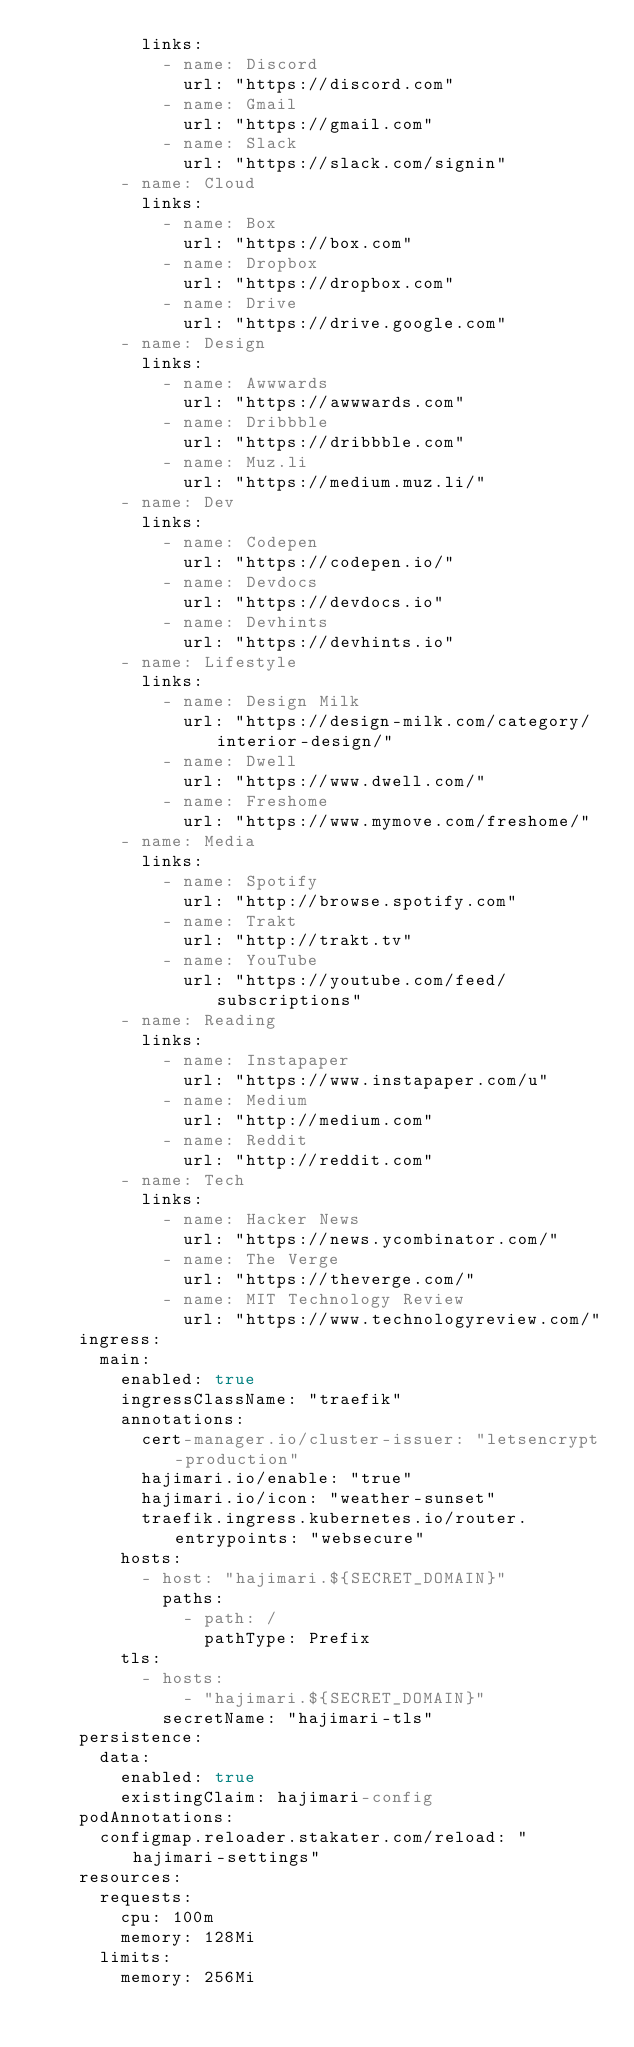Convert code to text. <code><loc_0><loc_0><loc_500><loc_500><_YAML_>          links:
            - name: Discord
              url: "https://discord.com"
            - name: Gmail
              url: "https://gmail.com"
            - name: Slack
              url: "https://slack.com/signin"
        - name: Cloud
          links:
            - name: Box
              url: "https://box.com"
            - name: Dropbox
              url: "https://dropbox.com"
            - name: Drive
              url: "https://drive.google.com"
        - name: Design
          links:
            - name: Awwwards
              url: "https://awwwards.com"
            - name: Dribbble
              url: "https://dribbble.com"
            - name: Muz.li
              url: "https://medium.muz.li/"
        - name: Dev
          links:
            - name: Codepen
              url: "https://codepen.io/"
            - name: Devdocs
              url: "https://devdocs.io"
            - name: Devhints
              url: "https://devhints.io"
        - name: Lifestyle
          links:
            - name: Design Milk
              url: "https://design-milk.com/category/interior-design/"
            - name: Dwell
              url: "https://www.dwell.com/"
            - name: Freshome
              url: "https://www.mymove.com/freshome/"
        - name: Media
          links:
            - name: Spotify
              url: "http://browse.spotify.com"
            - name: Trakt
              url: "http://trakt.tv"
            - name: YouTube
              url: "https://youtube.com/feed/subscriptions"
        - name: Reading
          links:
            - name: Instapaper
              url: "https://www.instapaper.com/u"
            - name: Medium
              url: "http://medium.com"
            - name: Reddit
              url: "http://reddit.com"
        - name: Tech
          links:
            - name: Hacker News
              url: "https://news.ycombinator.com/"
            - name: The Verge
              url: "https://theverge.com/"
            - name: MIT Technology Review
              url: "https://www.technologyreview.com/"
    ingress:
      main:
        enabled: true
        ingressClassName: "traefik"
        annotations:
          cert-manager.io/cluster-issuer: "letsencrypt-production"
          hajimari.io/enable: "true"
          hajimari.io/icon: "weather-sunset"
          traefik.ingress.kubernetes.io/router.entrypoints: "websecure"
        hosts:
          - host: "hajimari.${SECRET_DOMAIN}"
            paths:
              - path: /
                pathType: Prefix
        tls:
          - hosts:
              - "hajimari.${SECRET_DOMAIN}"
            secretName: "hajimari-tls"
    persistence:
      data:
        enabled: true
        existingClaim: hajimari-config
    podAnnotations:
      configmap.reloader.stakater.com/reload: "hajimari-settings"
    resources:
      requests:
        cpu: 100m
        memory: 128Mi
      limits:
        memory: 256Mi
</code> 